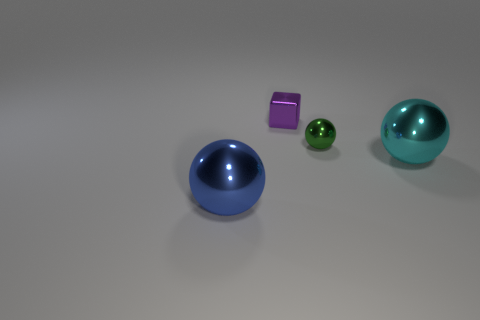What could these objects represent if they were metaphors? If these objects were metaphoric, the varying sizes and colors might represent diversity and individuality. The spherical shapes could symbolize completeness or unity, while the cube stands out as unique, possibly representing an outlier or a distinctive element within a group. 